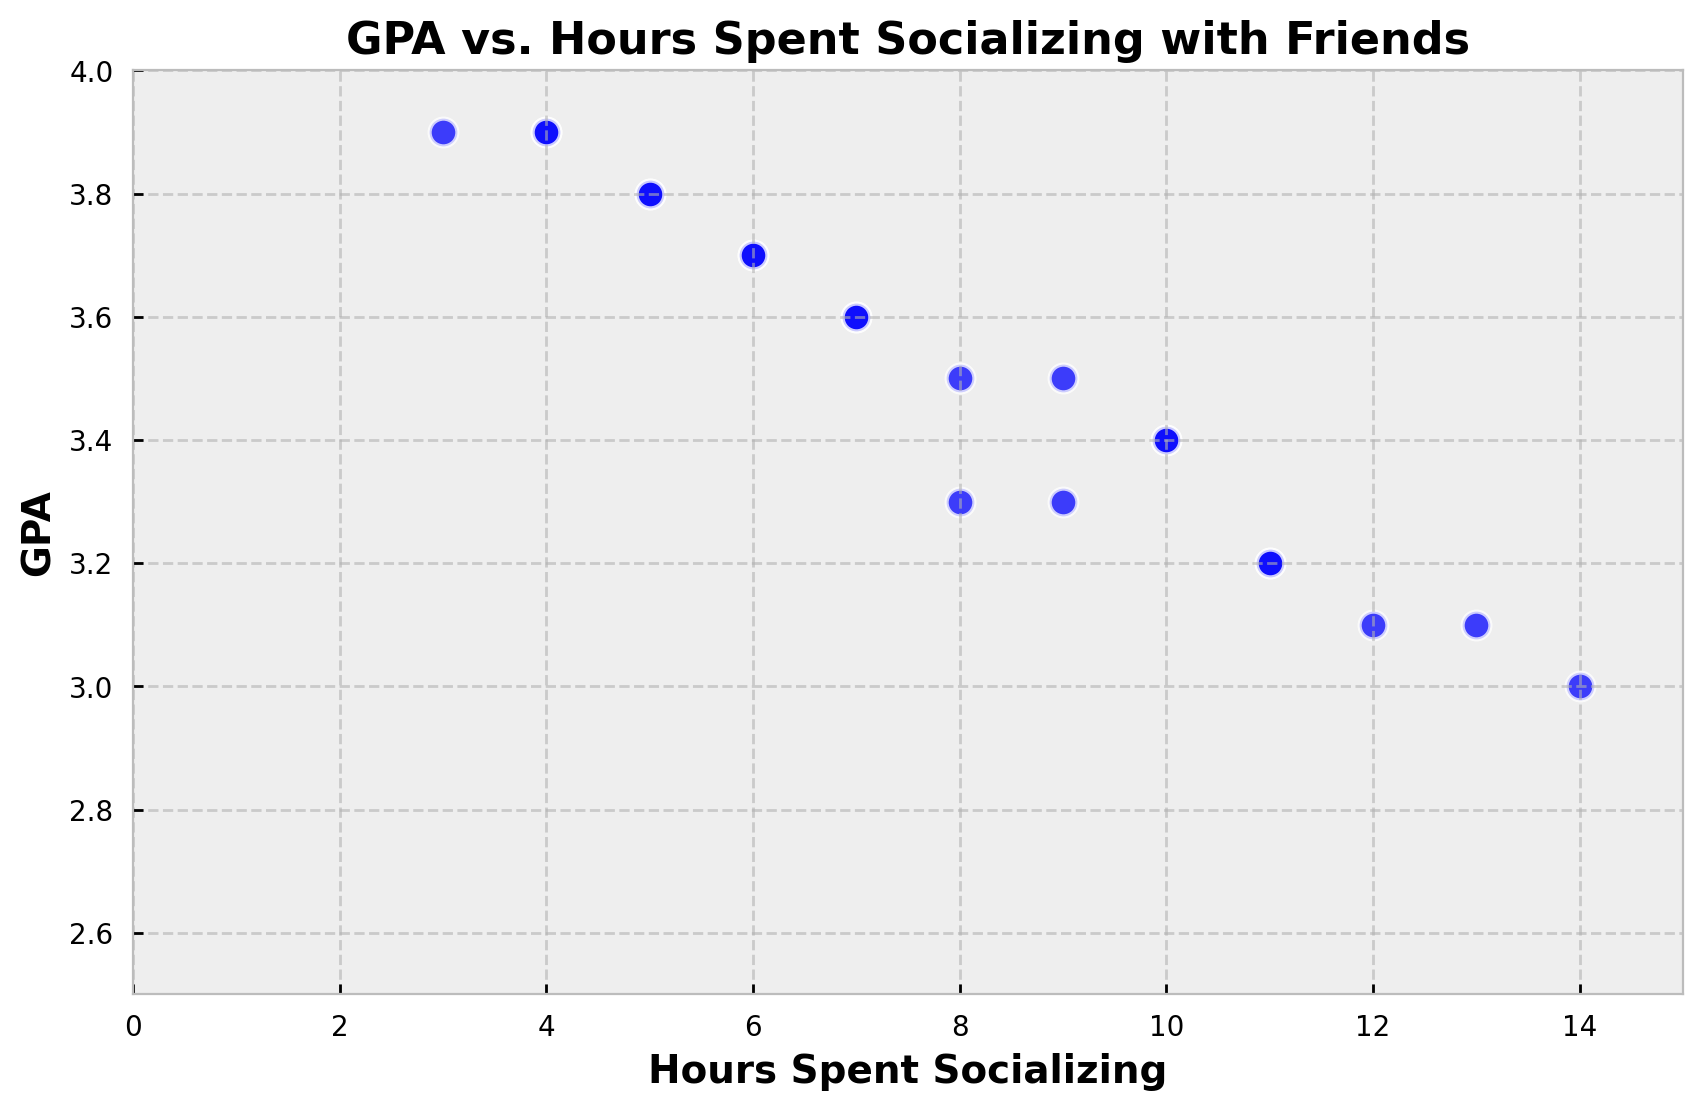What's the range of GPAs observed in the plot? The plot shows the highest GPA is 3.9 and the lowest GPA is 3.0. The range is calculated as 3.9 - 3.0.
Answer: 0.9 Is there a general trend between GPA and Hours Spent Socializing? By looking at the scatter plot, it seems that as the Hours Spent Socializing increases, GPA tends to decrease. This indicates a possible negative correlation.
Answer: Negative correlation What's the average number of Hours Spent Socializing? Sum all the Hours Spent Socializing values and divide by the total number of data points. (5 + 7 + 4 + 10 + 9 + 6 + 11 + 12 + 3 + 8 + 5 + 14 + 7 + 6 + 11 + 10 + 9 + 4 + 8 + 13) / 20 = 153 / 20 = 7.65
Answer: 7.65 Which data point represents the highest GPA, and how many hours is that student socializing? The highest GPA in the plot is 3.9, which appears at two points. The corresponding hours spent socializing are 4 and 3 hours.
Answer: 4 and 3 hours What’s the median number of Hours Spent Socializing? Sort the Hours Spent Socializing values and find the middle value. With an even number of data points, take the average of the two middle values: (5, 5, 6, 6, 7, 7, 8, 8, 9, 9, 10, 10, 11, 11, 12, 13, 14). The median is (9+8)/2=8.5
Answer: 8.5 Between GPAs of 3.0 and 3.4, how many hours do students spend socializing on average? Select the data points where GPA is between 3.0 and 3.4: (10, 11, 12, 14, 10, 9), and (13) sum these hours: 10 + 11 + 12 + 14 + 10 + 9 + 13 = 79, then divide by the number of such GPA values (7): 79 / 7 ≈ 11.29
Answer: 11.29 Which student socialized the least and what’s their GPA? Look for the data point with the lowest Hours Spent Socializing, which is 3 hours, and the corresponding GPA for this data point is 3.9
Answer: 3.9 Are there any outliers in the Hours Spent Socializing data, and what are they? Any data points that significantly deviate from the rest can be considered outliers. The highest value, 14 hours, appears much higher than the others.
Answer: 14 hours 